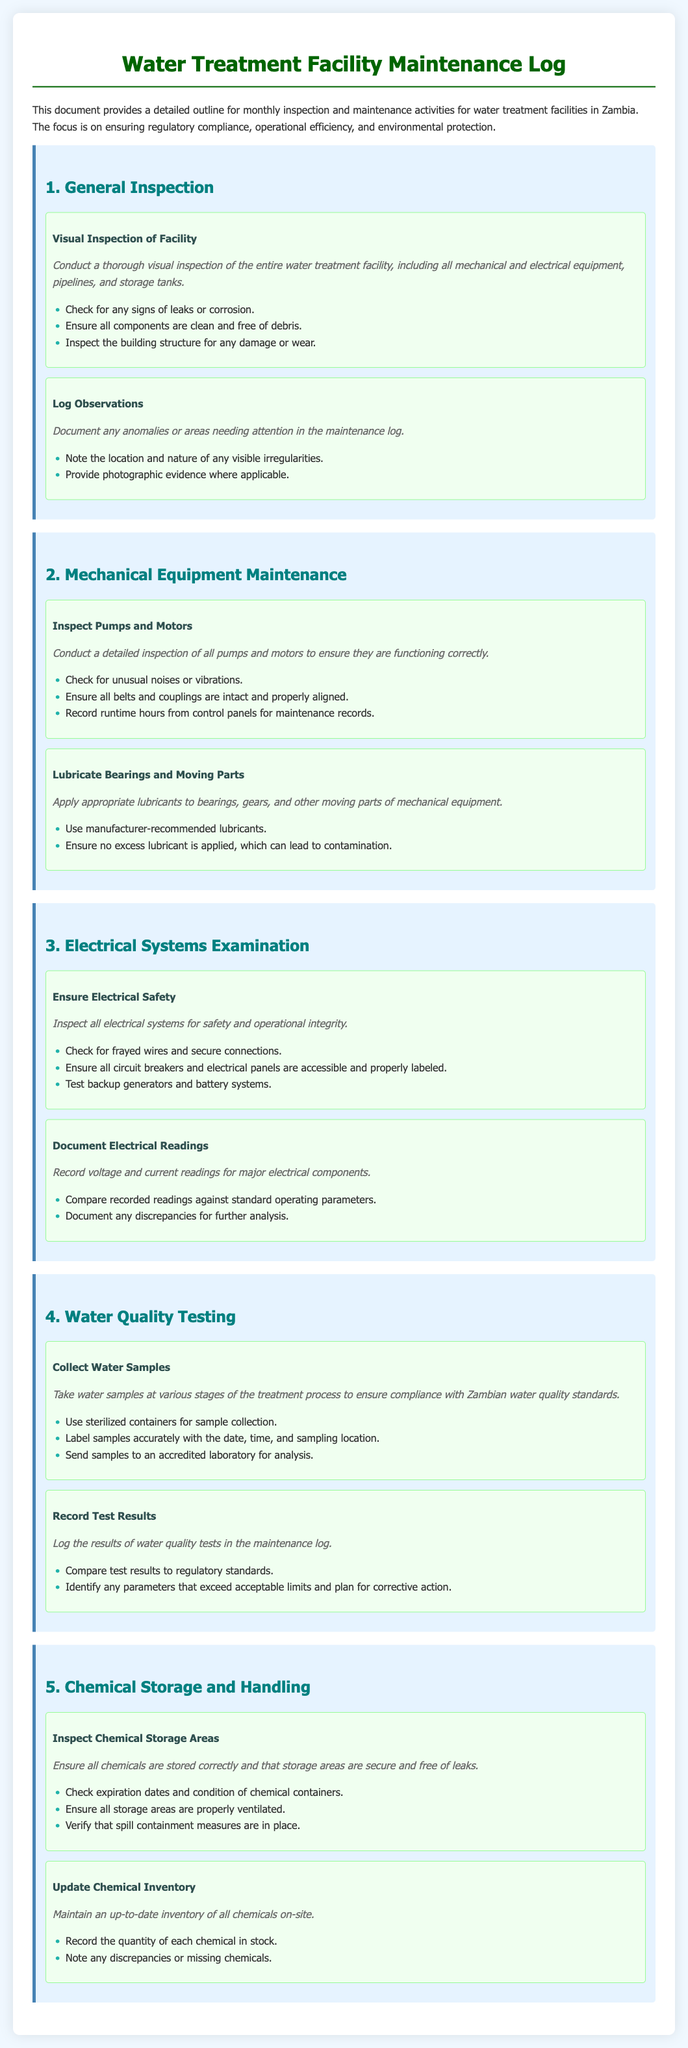what is the title of the document? The title of the document is mentioned at the top as "Water Treatment Facility Maintenance Log."
Answer: Water Treatment Facility Maintenance Log how many main sections are in the document? The document is divided into five main sections.
Answer: 5 what is the first procedure under General Inspection? The first procedure listed is "Visual Inspection of Facility."
Answer: Visual Inspection of Facility what type of equipment is inspected during Mechanical Equipment Maintenance? The equipment that is inspected includes "pumps and motors."
Answer: pumps and motors what should be recorded during Water Quality Testing? The test results of water quality should be logged in the maintenance log.
Answer: test results what must be checked in the Chemical Storage Areas? Inspection of "expiration dates and condition of chemical containers" is necessary.
Answer: expiration dates and condition of chemical containers what is one action to ensure Electrical Safety? One action is to "check for frayed wires and secure connections."
Answer: check for frayed wires and secure connections how are water samples collected? Water samples are collected using "sterilized containers."
Answer: sterilized containers what is required for documenting electrical readings? Voltage and current readings for major electrical components must be recorded.
Answer: recorded voltage and current readings 